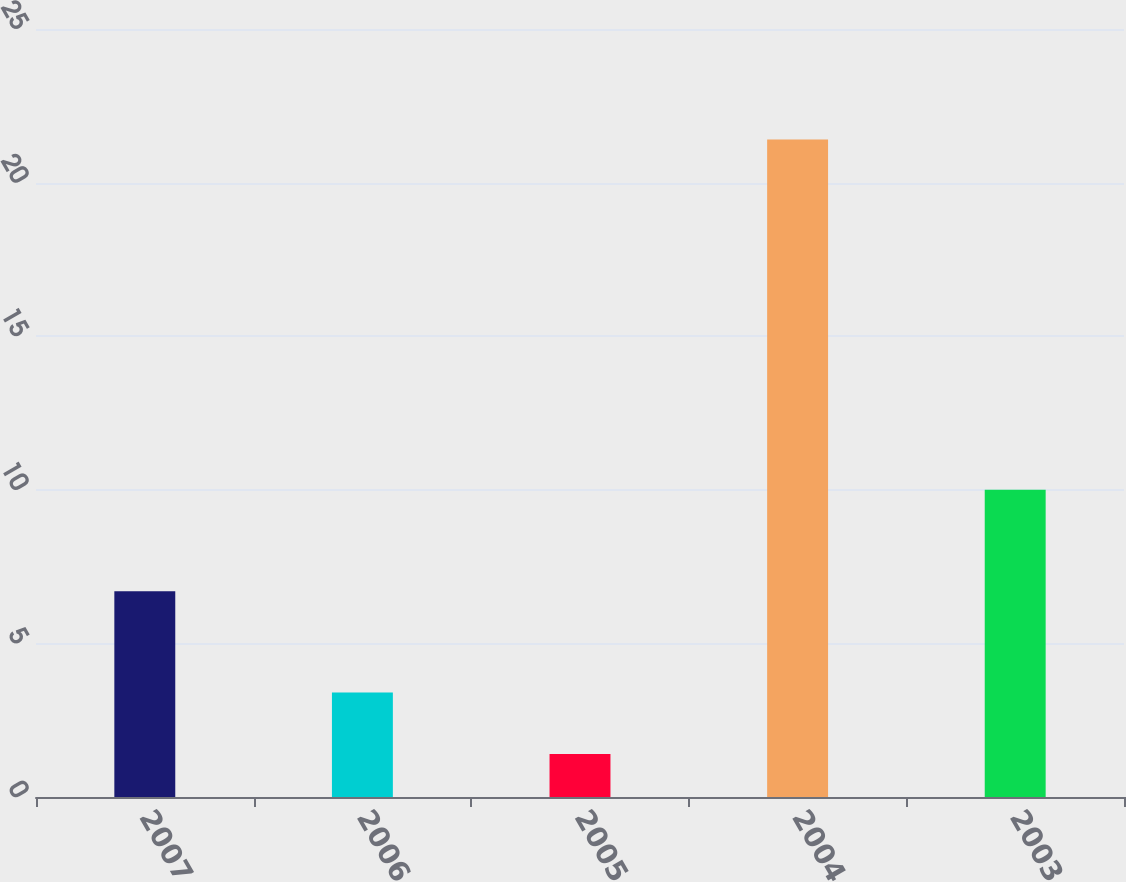Convert chart to OTSL. <chart><loc_0><loc_0><loc_500><loc_500><bar_chart><fcel>2007<fcel>2006<fcel>2005<fcel>2004<fcel>2003<nl><fcel>6.7<fcel>3.4<fcel>1.4<fcel>21.4<fcel>10<nl></chart> 